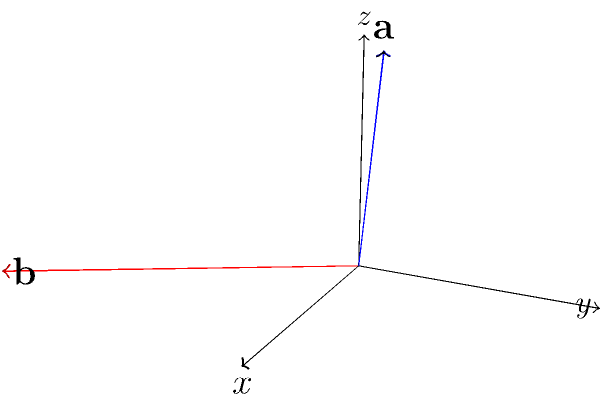As a content creator explaining vector operations in 3D space, you're writing a tutorial on finding angles between vectors. Given two position vectors $\mathbf{a} = (2, 1, 3)$ and $\mathbf{b} = (4, -2, 1)$ as shown in the diagram, calculate the angle $\theta$ between them using the dot product formula. Round your answer to the nearest degree. To find the angle between two vectors using the dot product formula, we'll follow these steps:

1) The formula for the angle $\theta$ between two vectors $\mathbf{a}$ and $\mathbf{b}$ is:

   $$\cos \theta = \frac{\mathbf{a} \cdot \mathbf{b}}{|\mathbf{a}||\mathbf{b}|}$$

2) Calculate the dot product $\mathbf{a} \cdot \mathbf{b}$:
   $$\mathbf{a} \cdot \mathbf{b} = (2)(4) + (1)(-2) + (3)(1) = 8 - 2 + 3 = 9$$

3) Calculate the magnitudes of the vectors:
   $$|\mathbf{a}| = \sqrt{2^2 + 1^2 + 3^2} = \sqrt{14}$$
   $$|\mathbf{b}| = \sqrt{4^2 + (-2)^2 + 1^2} = \sqrt{21}$$

4) Substitute these values into the formula:
   $$\cos \theta = \frac{9}{\sqrt{14}\sqrt{21}}$$

5) Solve for $\theta$ using the inverse cosine function:
   $$\theta = \arccos\left(\frac{9}{\sqrt{14}\sqrt{21}}\right)$$

6) Calculate and round to the nearest degree:
   $$\theta \approx 44.4°$$

   Rounding to the nearest degree gives us 44°.
Answer: 44° 